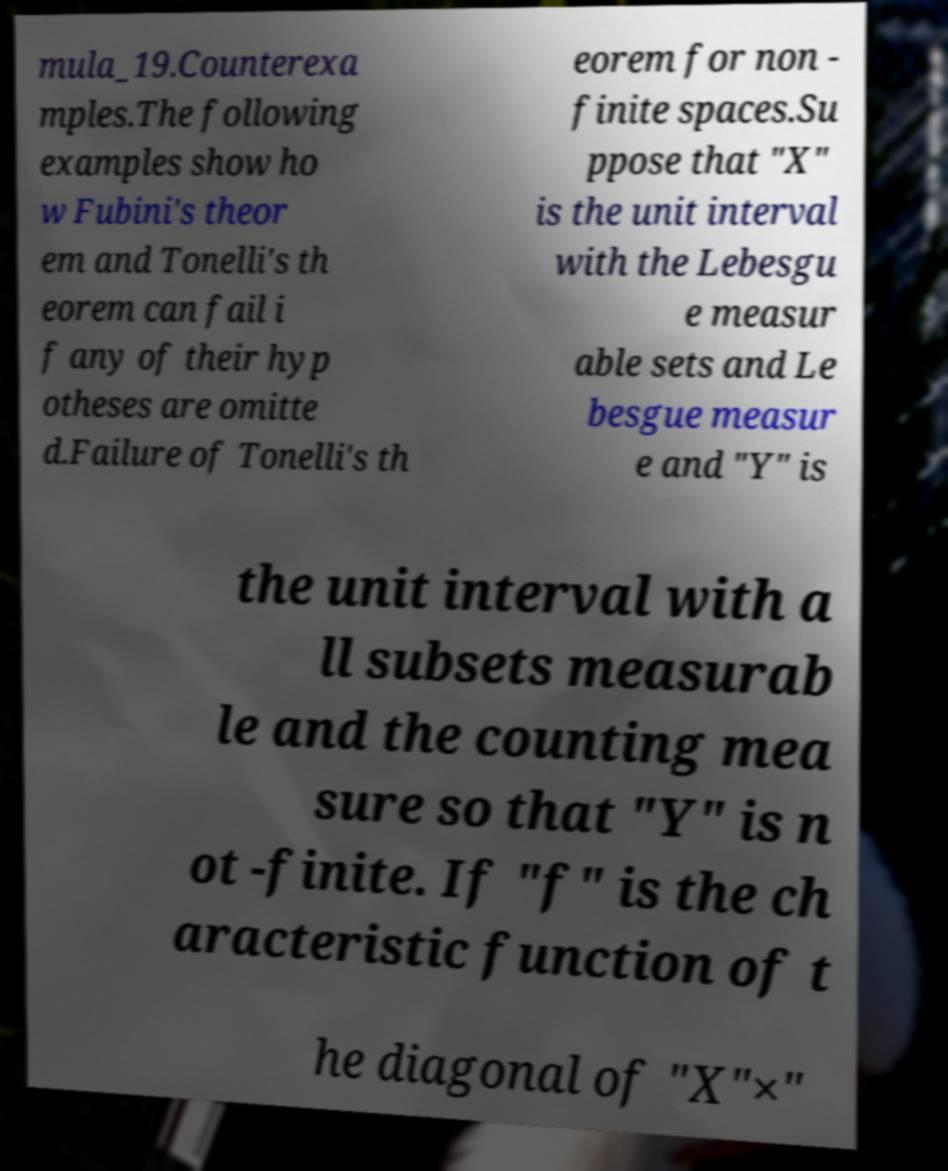I need the written content from this picture converted into text. Can you do that? mula_19.Counterexa mples.The following examples show ho w Fubini's theor em and Tonelli's th eorem can fail i f any of their hyp otheses are omitte d.Failure of Tonelli's th eorem for non - finite spaces.Su ppose that "X" is the unit interval with the Lebesgu e measur able sets and Le besgue measur e and "Y" is the unit interval with a ll subsets measurab le and the counting mea sure so that "Y" is n ot -finite. If "f" is the ch aracteristic function of t he diagonal of "X"×" 